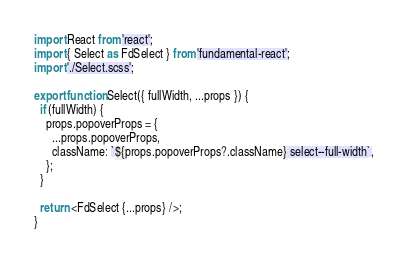Convert code to text. <code><loc_0><loc_0><loc_500><loc_500><_JavaScript_>import React from 'react';
import { Select as FdSelect } from 'fundamental-react';
import './Select.scss';

export function Select({ fullWidth, ...props }) {
  if (fullWidth) {
    props.popoverProps = {
      ...props.popoverProps,
      className: `${props.popoverProps?.className} select--full-width`,
    };
  }

  return <FdSelect {...props} />;
}
</code> 